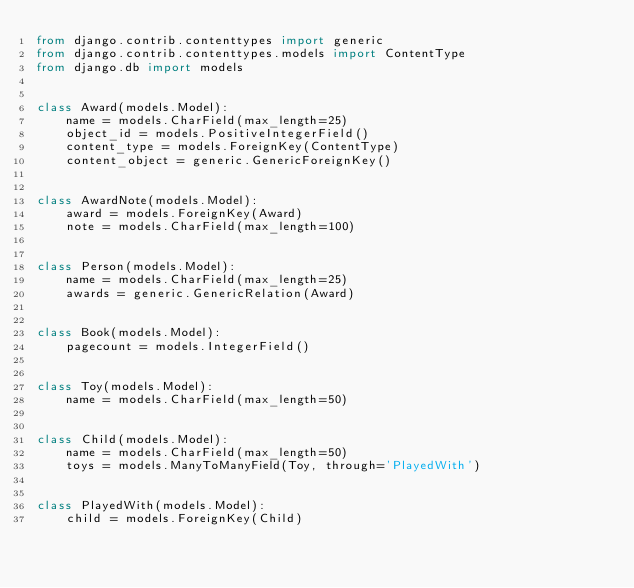<code> <loc_0><loc_0><loc_500><loc_500><_Python_>from django.contrib.contenttypes import generic
from django.contrib.contenttypes.models import ContentType
from django.db import models


class Award(models.Model):
    name = models.CharField(max_length=25)
    object_id = models.PositiveIntegerField()
    content_type = models.ForeignKey(ContentType)
    content_object = generic.GenericForeignKey()


class AwardNote(models.Model):
    award = models.ForeignKey(Award)
    note = models.CharField(max_length=100)


class Person(models.Model):
    name = models.CharField(max_length=25)
    awards = generic.GenericRelation(Award)


class Book(models.Model):
    pagecount = models.IntegerField()


class Toy(models.Model):
    name = models.CharField(max_length=50)


class Child(models.Model):
    name = models.CharField(max_length=50)
    toys = models.ManyToManyField(Toy, through='PlayedWith')


class PlayedWith(models.Model):
    child = models.ForeignKey(Child)</code> 